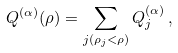Convert formula to latex. <formula><loc_0><loc_0><loc_500><loc_500>Q ^ { ( \alpha ) } ( \rho ) = \sum _ { j ( \rho _ { j } < \rho ) } Q ^ { ( \alpha ) } _ { j } \, ,</formula> 